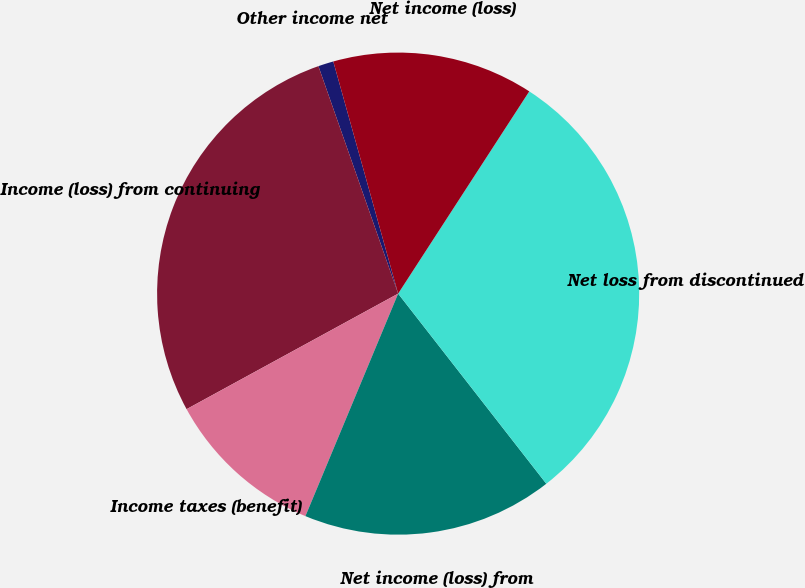Convert chart to OTSL. <chart><loc_0><loc_0><loc_500><loc_500><pie_chart><fcel>Other income net<fcel>Income (loss) from continuing<fcel>Income taxes (benefit)<fcel>Net income (loss) from<fcel>Net loss from discontinued<fcel>Net income (loss)<nl><fcel>1.03%<fcel>27.59%<fcel>10.76%<fcel>16.82%<fcel>30.31%<fcel>13.49%<nl></chart> 